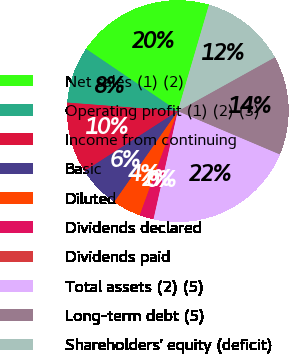Convert chart. <chart><loc_0><loc_0><loc_500><loc_500><pie_chart><fcel>Net sales (1) (2)<fcel>Operating profit (1) (2) (3)<fcel>Income from continuing<fcel>Basic<fcel>Diluted<fcel>Dividends declared<fcel>Dividends paid<fcel>Total assets (2) (5)<fcel>Long-term debt (5)<fcel>Shareholders' equity (deficit)<nl><fcel>20.06%<fcel>8.26%<fcel>10.32%<fcel>6.19%<fcel>4.13%<fcel>2.07%<fcel>0.0%<fcel>22.13%<fcel>14.45%<fcel>12.39%<nl></chart> 